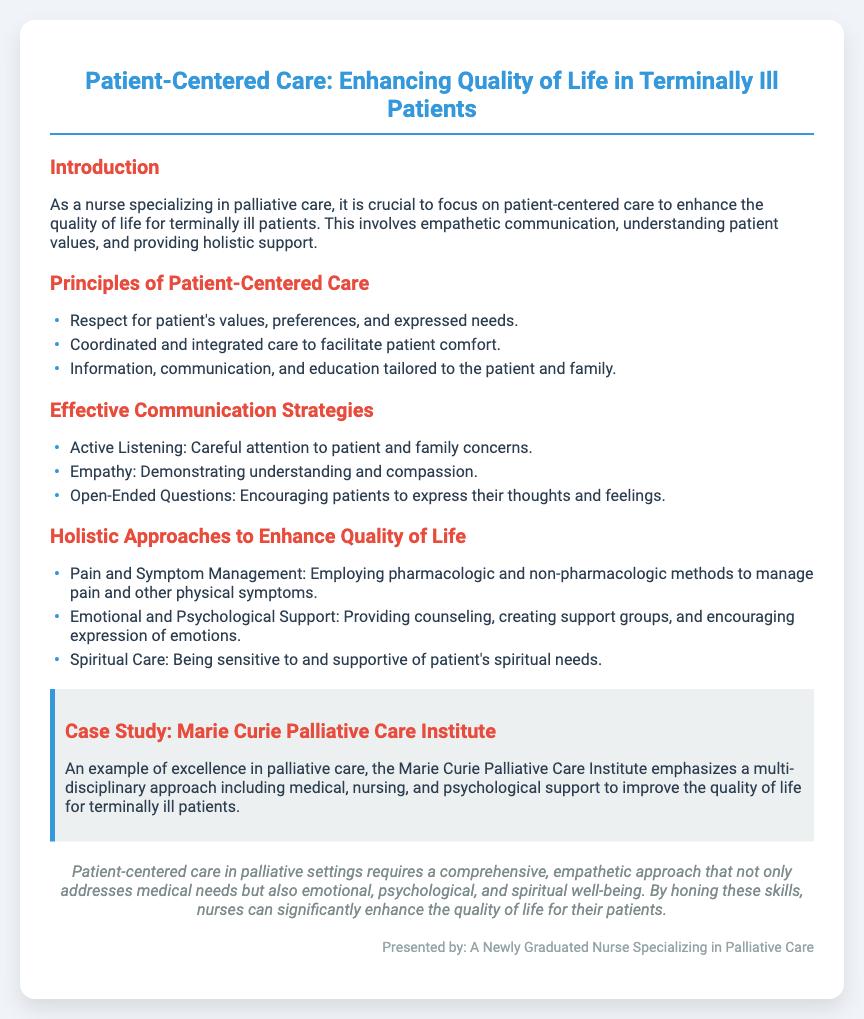What is the main focus of the presentation? The main focus of the presentation is on enhancing the quality of life for terminally ill patients through patient-centered care.
Answer: Patient-centered care What are the three principles of patient-centered care listed? The principles include respect for patient values, coordinated care, and tailored communication.
Answer: Respect for patient's values, preferences, and expressed needs; Coordinated and integrated care; Information, communication, and education tailored to the patient and family What does active listening entail in effective communication strategies? Active listening involves paying careful attention to patient and family concerns.
Answer: Careful attention to patient and family concerns Name one approach to enhance the quality of life mentioned in the document. The document outlines several holistic approaches, one of which is pain and symptom management.
Answer: Pain and Symptom Management What is emphasized in the case study related to the Marie Curie Palliative Care Institute? The emphasis is on a multi-disciplinary approach to improve the quality of life for terminally ill patients.
Answer: A multi-disciplinary approach How does the conclusion summarize the care approach in palliative settings? The conclusion indicates a comprehensive and empathetic approach is required to address medical and emotional needs.
Answer: A comprehensive, empathetic approach What type of support is provided for emotional well-being according to holistic approaches? Emotional and psychological support includes counseling and support groups.
Answer: Providing counseling, creating support groups What color is used for the headings in the presentation? The headings are styled in a specific color to enhance visual appeal.
Answer: #3498db 